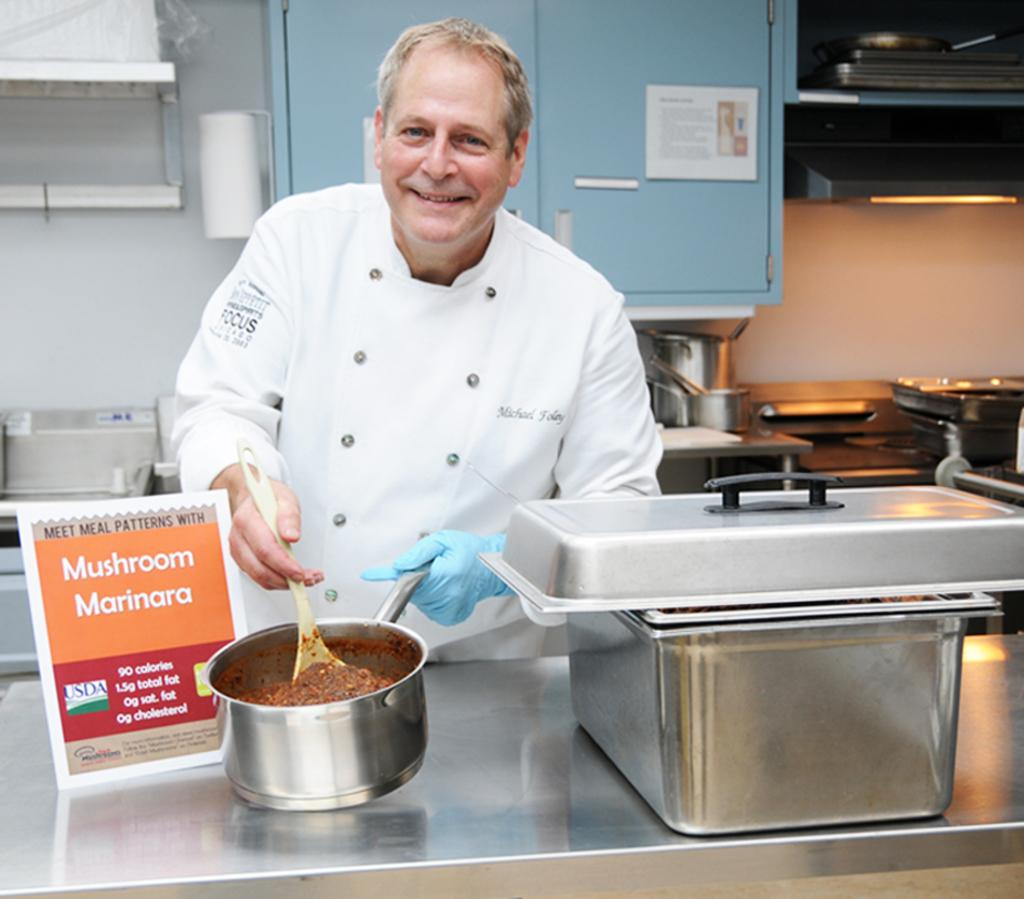Provide a one-sentence caption for the provided image. A chief cooking mushroom marinara with the brand Focus on arm of shirt. 